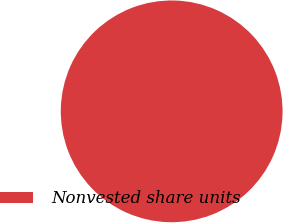Convert chart. <chart><loc_0><loc_0><loc_500><loc_500><pie_chart><fcel>Nonvested share units<nl><fcel>100.0%<nl></chart> 